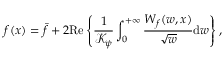<formula> <loc_0><loc_0><loc_500><loc_500>f ( x ) = \bar { f } + 2 R e \left \{ \frac { 1 } { \mathcal { K } _ { \psi } } \int _ { 0 } ^ { + \infty } \frac { W _ { f } ( w , x ) } { \sqrt { w } } d w \right \} ,</formula> 